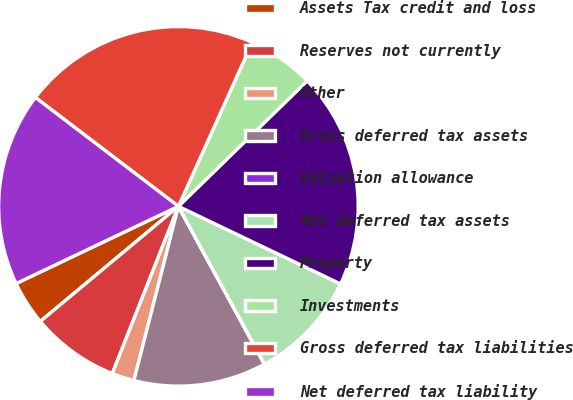Convert chart to OTSL. <chart><loc_0><loc_0><loc_500><loc_500><pie_chart><fcel>Assets Tax credit and loss<fcel>Reserves not currently<fcel>Other<fcel>Gross deferred tax assets<fcel>Valuation allowance<fcel>Net deferred tax assets<fcel>Property<fcel>Investments<fcel>Gross deferred tax liabilities<fcel>Net deferred tax liability<nl><fcel>3.99%<fcel>7.95%<fcel>2.01%<fcel>11.92%<fcel>0.02%<fcel>9.94%<fcel>19.4%<fcel>5.97%<fcel>21.38%<fcel>17.42%<nl></chart> 